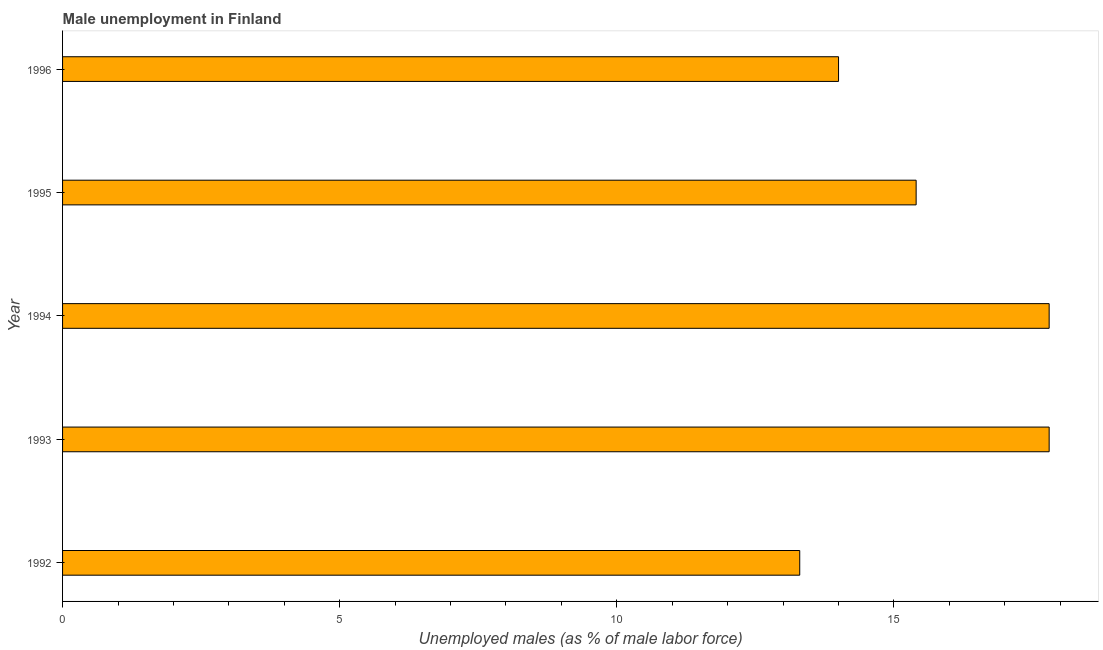Does the graph contain grids?
Your answer should be compact. No. What is the title of the graph?
Your answer should be compact. Male unemployment in Finland. What is the label or title of the X-axis?
Offer a terse response. Unemployed males (as % of male labor force). What is the unemployed males population in 1992?
Ensure brevity in your answer.  13.3. Across all years, what is the maximum unemployed males population?
Give a very brief answer. 17.8. Across all years, what is the minimum unemployed males population?
Provide a succinct answer. 13.3. In which year was the unemployed males population maximum?
Ensure brevity in your answer.  1993. In which year was the unemployed males population minimum?
Your answer should be very brief. 1992. What is the sum of the unemployed males population?
Your answer should be very brief. 78.3. What is the average unemployed males population per year?
Give a very brief answer. 15.66. What is the median unemployed males population?
Give a very brief answer. 15.4. In how many years, is the unemployed males population greater than 12 %?
Your answer should be compact. 5. What is the ratio of the unemployed males population in 1992 to that in 1993?
Your response must be concise. 0.75. What is the difference between the highest and the second highest unemployed males population?
Make the answer very short. 0. What is the difference between the highest and the lowest unemployed males population?
Make the answer very short. 4.5. How many bars are there?
Give a very brief answer. 5. Are all the bars in the graph horizontal?
Offer a very short reply. Yes. How many years are there in the graph?
Your answer should be compact. 5. What is the difference between two consecutive major ticks on the X-axis?
Provide a short and direct response. 5. What is the Unemployed males (as % of male labor force) in 1992?
Ensure brevity in your answer.  13.3. What is the Unemployed males (as % of male labor force) of 1993?
Make the answer very short. 17.8. What is the Unemployed males (as % of male labor force) in 1994?
Provide a succinct answer. 17.8. What is the Unemployed males (as % of male labor force) in 1995?
Your answer should be very brief. 15.4. What is the Unemployed males (as % of male labor force) in 1996?
Keep it short and to the point. 14. What is the difference between the Unemployed males (as % of male labor force) in 1992 and 1993?
Provide a succinct answer. -4.5. What is the difference between the Unemployed males (as % of male labor force) in 1992 and 1994?
Provide a short and direct response. -4.5. What is the difference between the Unemployed males (as % of male labor force) in 1992 and 1996?
Provide a short and direct response. -0.7. What is the difference between the Unemployed males (as % of male labor force) in 1993 and 1994?
Give a very brief answer. 0. What is the difference between the Unemployed males (as % of male labor force) in 1993 and 1995?
Offer a terse response. 2.4. What is the difference between the Unemployed males (as % of male labor force) in 1994 and 1995?
Offer a very short reply. 2.4. What is the difference between the Unemployed males (as % of male labor force) in 1994 and 1996?
Your answer should be very brief. 3.8. What is the difference between the Unemployed males (as % of male labor force) in 1995 and 1996?
Offer a terse response. 1.4. What is the ratio of the Unemployed males (as % of male labor force) in 1992 to that in 1993?
Your response must be concise. 0.75. What is the ratio of the Unemployed males (as % of male labor force) in 1992 to that in 1994?
Keep it short and to the point. 0.75. What is the ratio of the Unemployed males (as % of male labor force) in 1992 to that in 1995?
Ensure brevity in your answer.  0.86. What is the ratio of the Unemployed males (as % of male labor force) in 1992 to that in 1996?
Provide a succinct answer. 0.95. What is the ratio of the Unemployed males (as % of male labor force) in 1993 to that in 1995?
Provide a short and direct response. 1.16. What is the ratio of the Unemployed males (as % of male labor force) in 1993 to that in 1996?
Give a very brief answer. 1.27. What is the ratio of the Unemployed males (as % of male labor force) in 1994 to that in 1995?
Provide a short and direct response. 1.16. What is the ratio of the Unemployed males (as % of male labor force) in 1994 to that in 1996?
Offer a very short reply. 1.27. 